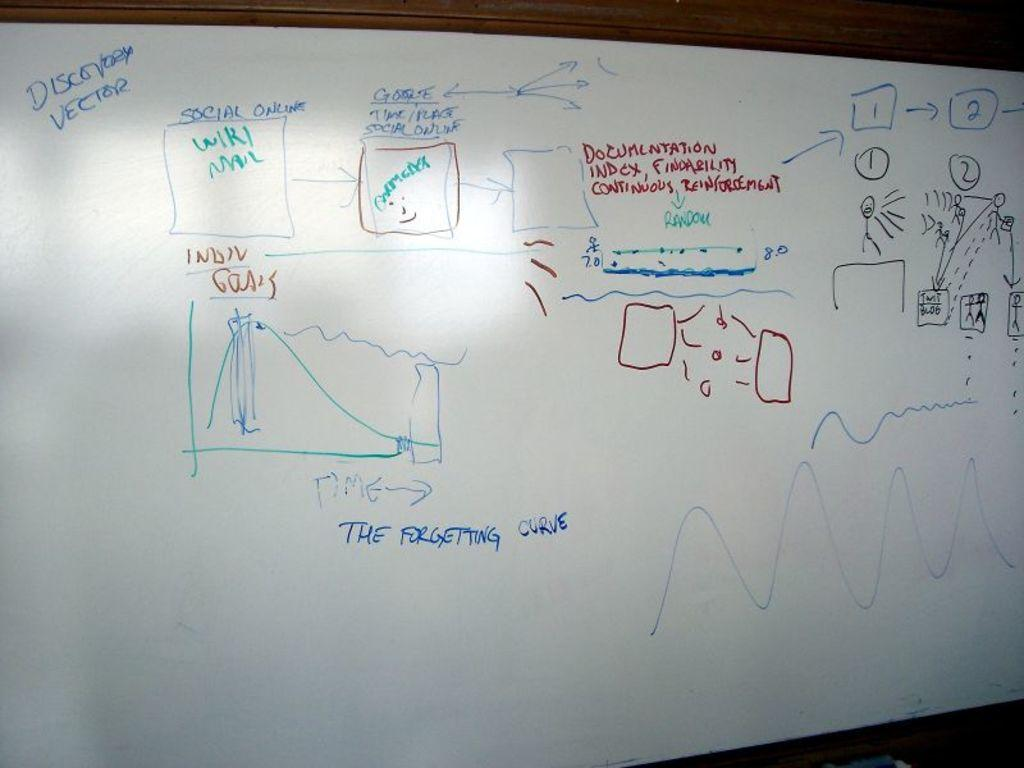<image>
Offer a succinct explanation of the picture presented. the words discovery vector that is on a white board 